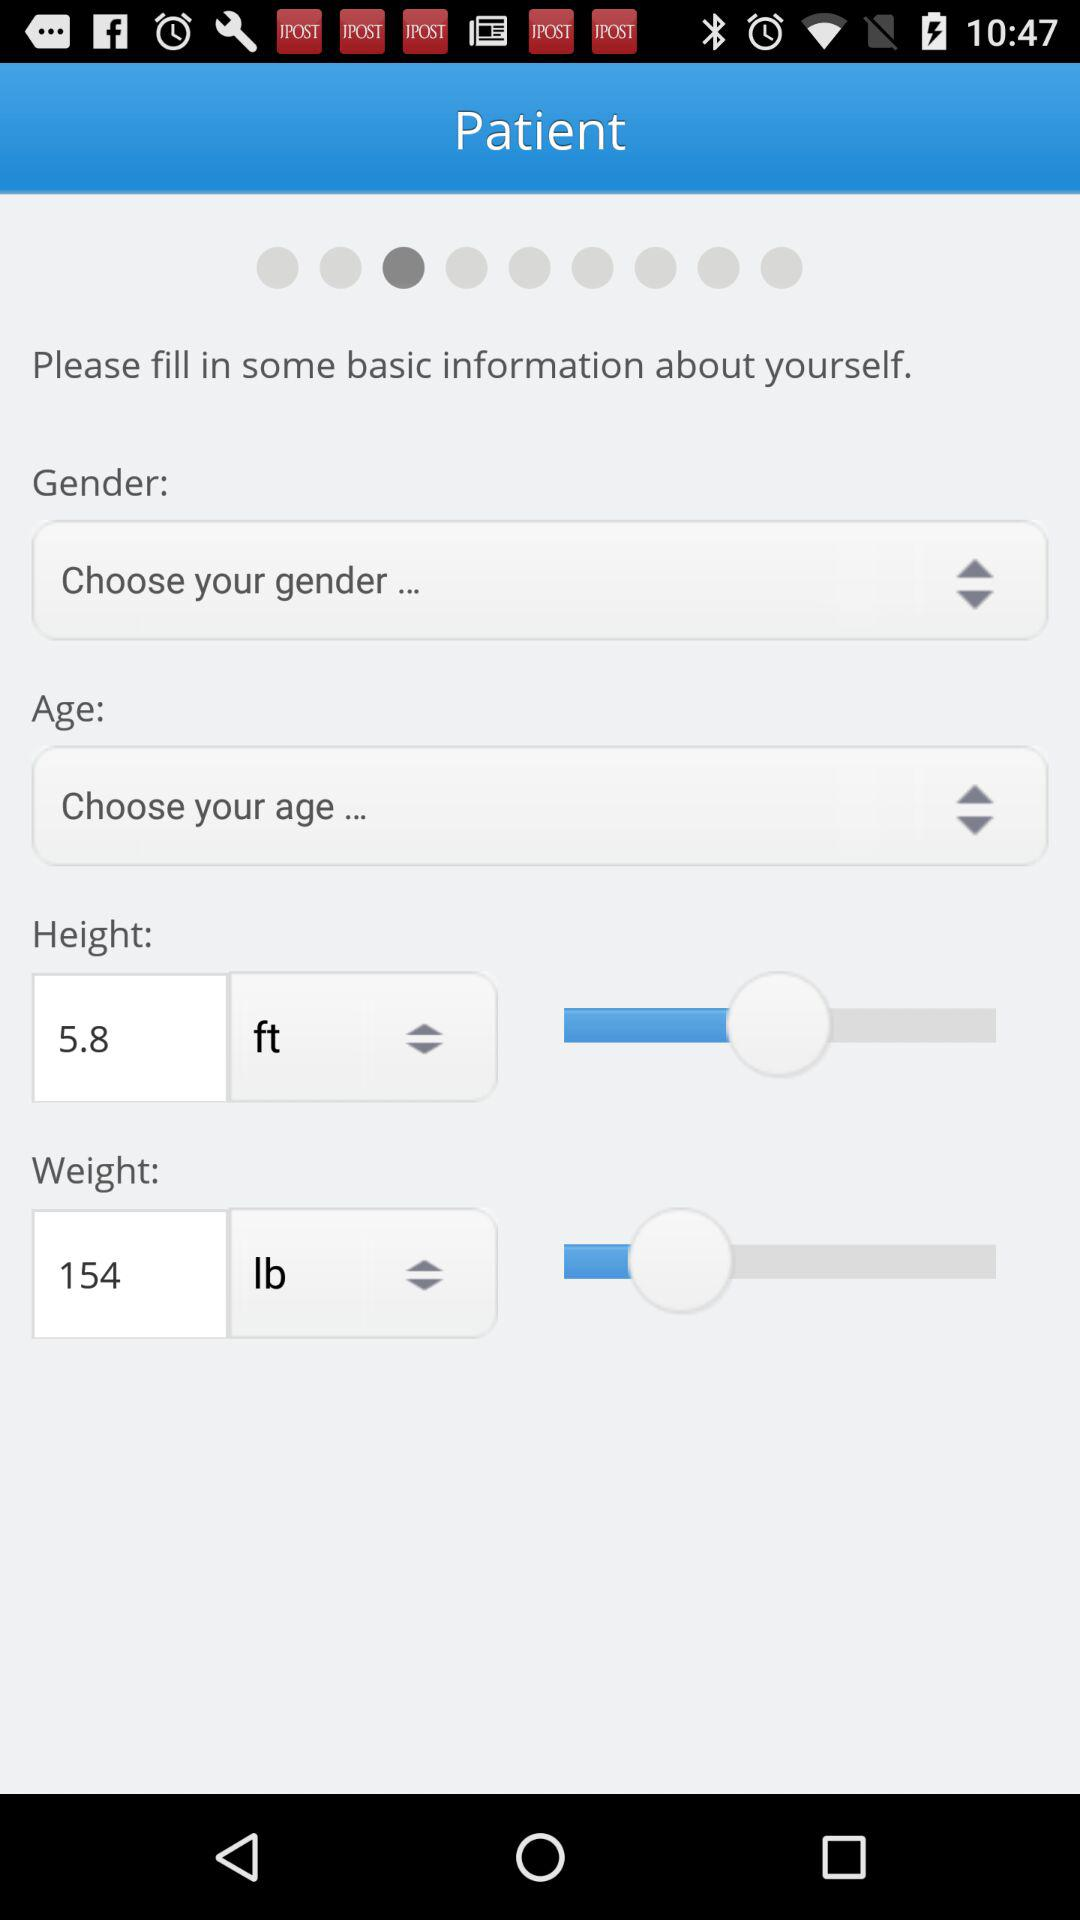Which gender was chosen?
When the provided information is insufficient, respond with <no answer>. <no answer> 